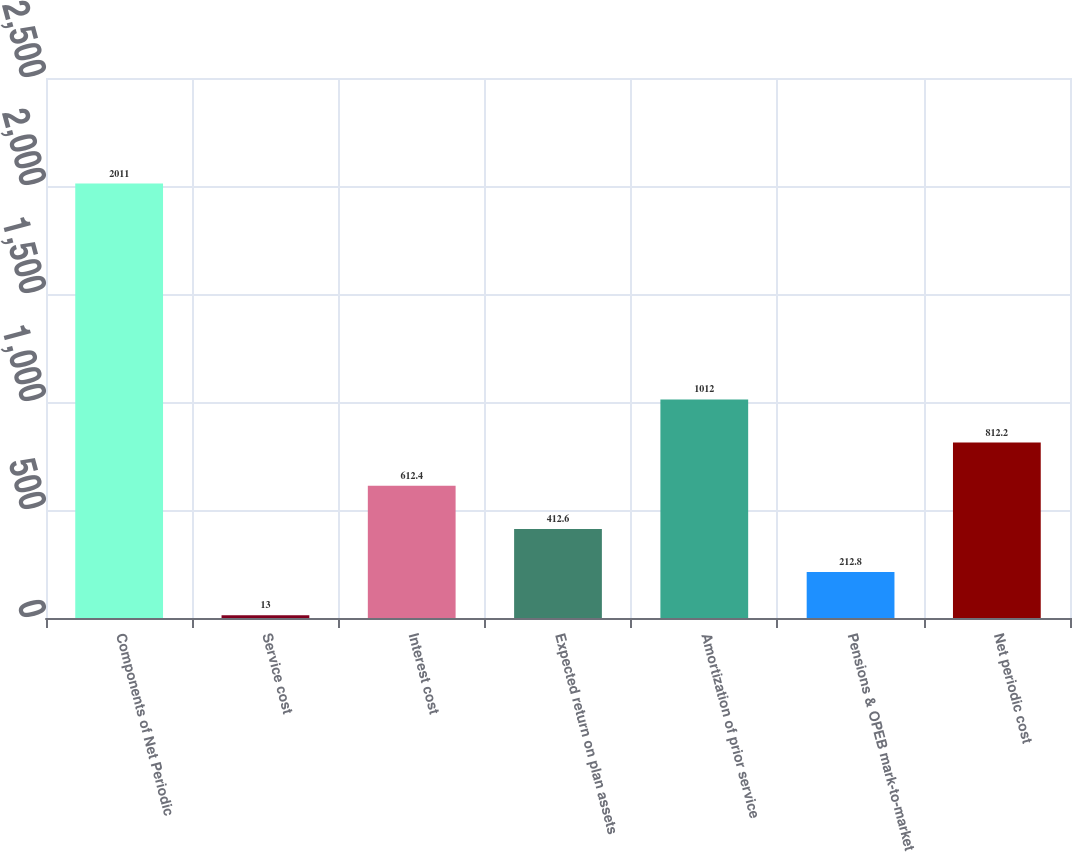Convert chart. <chart><loc_0><loc_0><loc_500><loc_500><bar_chart><fcel>Components of Net Periodic<fcel>Service cost<fcel>Interest cost<fcel>Expected return on plan assets<fcel>Amortization of prior service<fcel>Pensions & OPEB mark-to-market<fcel>Net periodic cost<nl><fcel>2011<fcel>13<fcel>612.4<fcel>412.6<fcel>1012<fcel>212.8<fcel>812.2<nl></chart> 